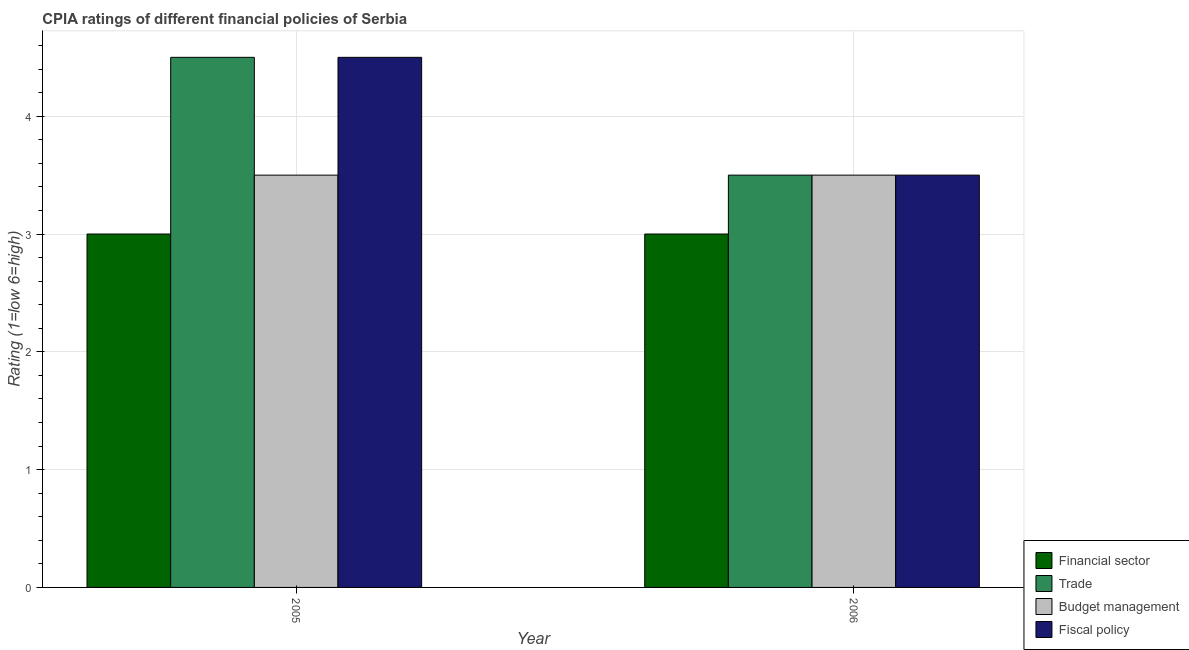How many different coloured bars are there?
Ensure brevity in your answer.  4. Are the number of bars per tick equal to the number of legend labels?
Your response must be concise. Yes. Are the number of bars on each tick of the X-axis equal?
Your response must be concise. Yes. How many bars are there on the 2nd tick from the left?
Offer a very short reply. 4. In how many cases, is the number of bars for a given year not equal to the number of legend labels?
Your answer should be compact. 0. What is the cpia rating of financial sector in 2005?
Ensure brevity in your answer.  3. Across all years, what is the maximum cpia rating of fiscal policy?
Your answer should be very brief. 4.5. In which year was the cpia rating of financial sector minimum?
Keep it short and to the point. 2005. What is the total cpia rating of trade in the graph?
Your answer should be compact. 8. What is the difference between the cpia rating of financial sector in 2005 and that in 2006?
Your response must be concise. 0. What is the difference between the cpia rating of fiscal policy in 2005 and the cpia rating of financial sector in 2006?
Make the answer very short. 1. In how many years, is the cpia rating of trade greater than 1.8?
Offer a terse response. 2. What is the ratio of the cpia rating of trade in 2005 to that in 2006?
Your response must be concise. 1.29. What does the 1st bar from the left in 2005 represents?
Provide a short and direct response. Financial sector. What does the 4th bar from the right in 2005 represents?
Offer a very short reply. Financial sector. How many bars are there?
Make the answer very short. 8. How many years are there in the graph?
Offer a very short reply. 2. What is the difference between two consecutive major ticks on the Y-axis?
Make the answer very short. 1. Are the values on the major ticks of Y-axis written in scientific E-notation?
Your answer should be very brief. No. Does the graph contain any zero values?
Keep it short and to the point. No. How are the legend labels stacked?
Your answer should be very brief. Vertical. What is the title of the graph?
Provide a succinct answer. CPIA ratings of different financial policies of Serbia. What is the label or title of the Y-axis?
Offer a terse response. Rating (1=low 6=high). What is the Rating (1=low 6=high) in Financial sector in 2005?
Your answer should be very brief. 3. What is the Rating (1=low 6=high) in Fiscal policy in 2005?
Provide a succinct answer. 4.5. What is the Rating (1=low 6=high) in Budget management in 2006?
Provide a short and direct response. 3.5. Across all years, what is the maximum Rating (1=low 6=high) of Trade?
Offer a terse response. 4.5. Across all years, what is the maximum Rating (1=low 6=high) in Budget management?
Provide a short and direct response. 3.5. Across all years, what is the maximum Rating (1=low 6=high) of Fiscal policy?
Offer a very short reply. 4.5. Across all years, what is the minimum Rating (1=low 6=high) of Financial sector?
Your answer should be very brief. 3. Across all years, what is the minimum Rating (1=low 6=high) in Budget management?
Provide a short and direct response. 3.5. What is the total Rating (1=low 6=high) in Financial sector in the graph?
Your answer should be compact. 6. What is the total Rating (1=low 6=high) in Trade in the graph?
Your answer should be compact. 8. What is the total Rating (1=low 6=high) of Fiscal policy in the graph?
Offer a very short reply. 8. What is the difference between the Rating (1=low 6=high) in Financial sector in 2005 and the Rating (1=low 6=high) in Budget management in 2006?
Offer a terse response. -0.5. What is the difference between the Rating (1=low 6=high) in Financial sector in 2005 and the Rating (1=low 6=high) in Fiscal policy in 2006?
Provide a short and direct response. -0.5. What is the difference between the Rating (1=low 6=high) of Budget management in 2005 and the Rating (1=low 6=high) of Fiscal policy in 2006?
Give a very brief answer. 0. What is the average Rating (1=low 6=high) in Trade per year?
Ensure brevity in your answer.  4. What is the average Rating (1=low 6=high) of Budget management per year?
Offer a terse response. 3.5. What is the average Rating (1=low 6=high) of Fiscal policy per year?
Give a very brief answer. 4. In the year 2005, what is the difference between the Rating (1=low 6=high) of Trade and Rating (1=low 6=high) of Fiscal policy?
Ensure brevity in your answer.  0. In the year 2005, what is the difference between the Rating (1=low 6=high) in Budget management and Rating (1=low 6=high) in Fiscal policy?
Keep it short and to the point. -1. In the year 2006, what is the difference between the Rating (1=low 6=high) of Financial sector and Rating (1=low 6=high) of Budget management?
Provide a short and direct response. -0.5. In the year 2006, what is the difference between the Rating (1=low 6=high) of Financial sector and Rating (1=low 6=high) of Fiscal policy?
Offer a very short reply. -0.5. In the year 2006, what is the difference between the Rating (1=low 6=high) in Budget management and Rating (1=low 6=high) in Fiscal policy?
Your response must be concise. 0. What is the ratio of the Rating (1=low 6=high) in Trade in 2005 to that in 2006?
Ensure brevity in your answer.  1.29. What is the ratio of the Rating (1=low 6=high) of Fiscal policy in 2005 to that in 2006?
Offer a terse response. 1.29. What is the difference between the highest and the second highest Rating (1=low 6=high) in Budget management?
Make the answer very short. 0. What is the difference between the highest and the second highest Rating (1=low 6=high) in Fiscal policy?
Ensure brevity in your answer.  1. What is the difference between the highest and the lowest Rating (1=low 6=high) of Budget management?
Your answer should be very brief. 0. What is the difference between the highest and the lowest Rating (1=low 6=high) of Fiscal policy?
Ensure brevity in your answer.  1. 